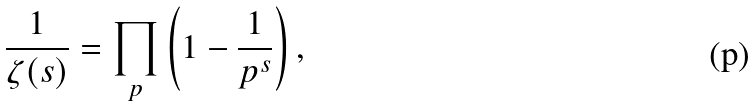<formula> <loc_0><loc_0><loc_500><loc_500>\frac { 1 } { \zeta ( s ) } = \prod _ { p } \left ( 1 - \frac { 1 } { p ^ { s } } \right ) ,</formula> 